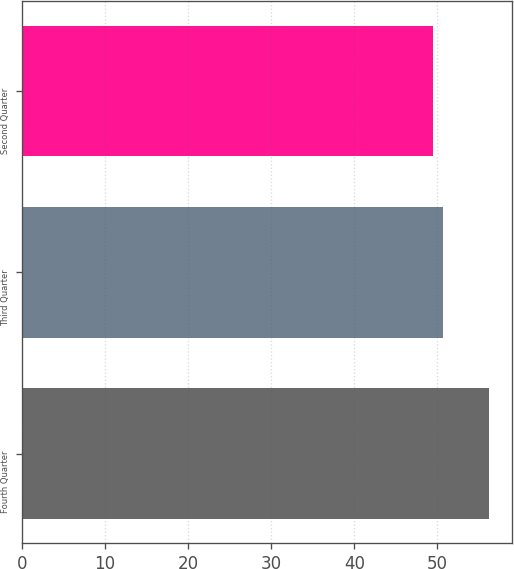<chart> <loc_0><loc_0><loc_500><loc_500><bar_chart><fcel>Fourth Quarter<fcel>Third Quarter<fcel>Second Quarter<nl><fcel>56.19<fcel>50.71<fcel>49.5<nl></chart> 